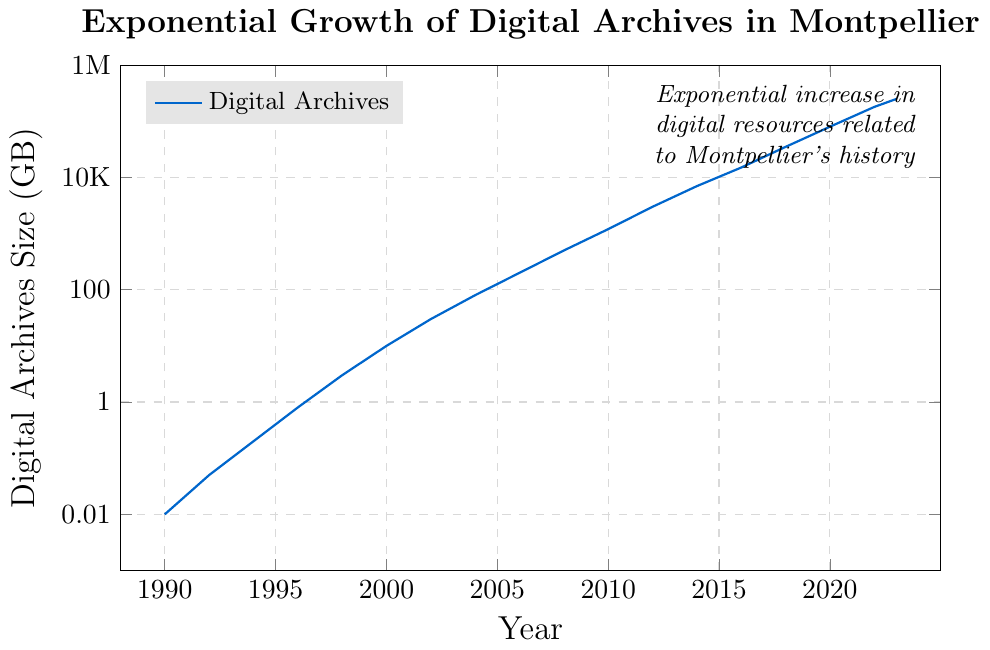What is the general trend of digital archives size from 1990 to 2023? The figure shows a logscale plot, indicating that the size of digital archives has been increasing exponentially over the years. This is evidenced by the steady upward curve on the logscale chart.
Answer: Increasing exponentially What is the size of digital archives in 2010? On the figure, locate the year 2010 on the x-axis and find the corresponding value on the y-axis. The label closest to this point indicates that the size of digital archives in 2010 is around 1200 GB.
Answer: 1200 GB By what factor did the digital archives increase from 1990 to 2000? In 1990, the size was 0.01 GB, and in 2000, it was 10 GB. The factor of increase is calculated as 10 / 0.01.
Answer: 1000 How does the growth of digital archives between 2000 and 2010 compare to the growth between 2010 and 2020? From 2000 to 2010, the size increased from 10 GB to 1200 GB, an increase by a factor of 120 (1200/10). From 2010 to 2020, it went from 1200 GB to 80000 GB, an increase by a factor of approximately 66.67 (80000/1200).
Answer: Growth was more rapid from 2000 to 2010 What was the difference in size of digital archives between 2016 and 2018? From 2016, the size was 15000 GB, and in 2018, it was 35000 GB. The difference is calculated as 35000 - 15000.
Answer: 20000 GB What significant visual pattern can be observed about the data plot on the logscale chart? The logscale chart shows that the data points form a straight line with a steep positive slope, indicating exponential growth of digital archives over time.
Answer: Exponential growth pattern By approximately how many GB did the digital archives size increase between 2020 and 2023? In 2020, the size was 80000 GB, and in 2023, it was 250000 GB. The increase is calculated as 250000 - 80000.
Answer: 170000 GB Which year had the smallest increase in digital archives size compared to the previous recorded year? Analyzing the difference between consecutive years indicates that from 1990 to 1992, the increase was 0.05 - 0.01 = 0.04 GB, which is the smallest.
Answer: 1992 